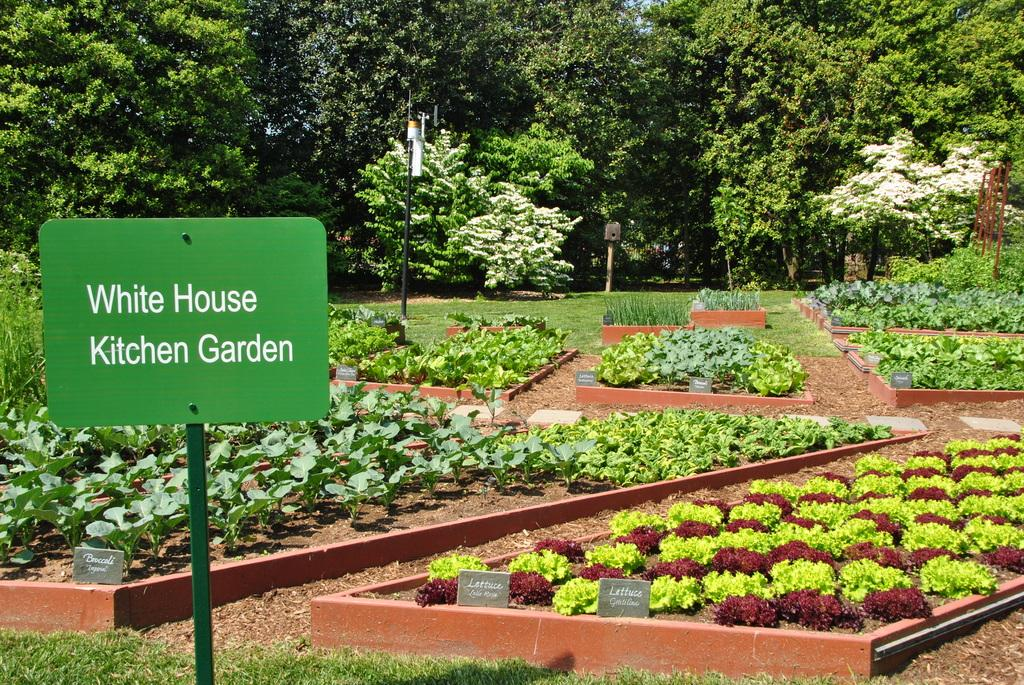What type of environment is shown in the image? The image depicts a garden. What type of vegetation can be seen in the garden? There are trees and small plants in the garden. What is the ground covered with in the garden? Grass is present in the garden. Is there any signage or text in the garden? Yes, there is a board with text in the garden. How many seeds are visible on the mask in the image? There is no mask or seeds present in the image. 